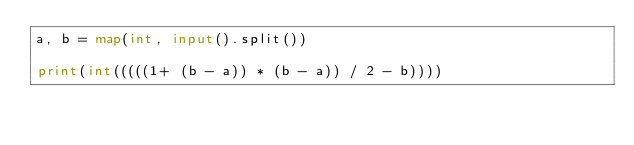<code> <loc_0><loc_0><loc_500><loc_500><_Python_>a, b = map(int, input().split())

print(int(((((1+ (b - a)) * (b - a)) / 2 - b))))</code> 